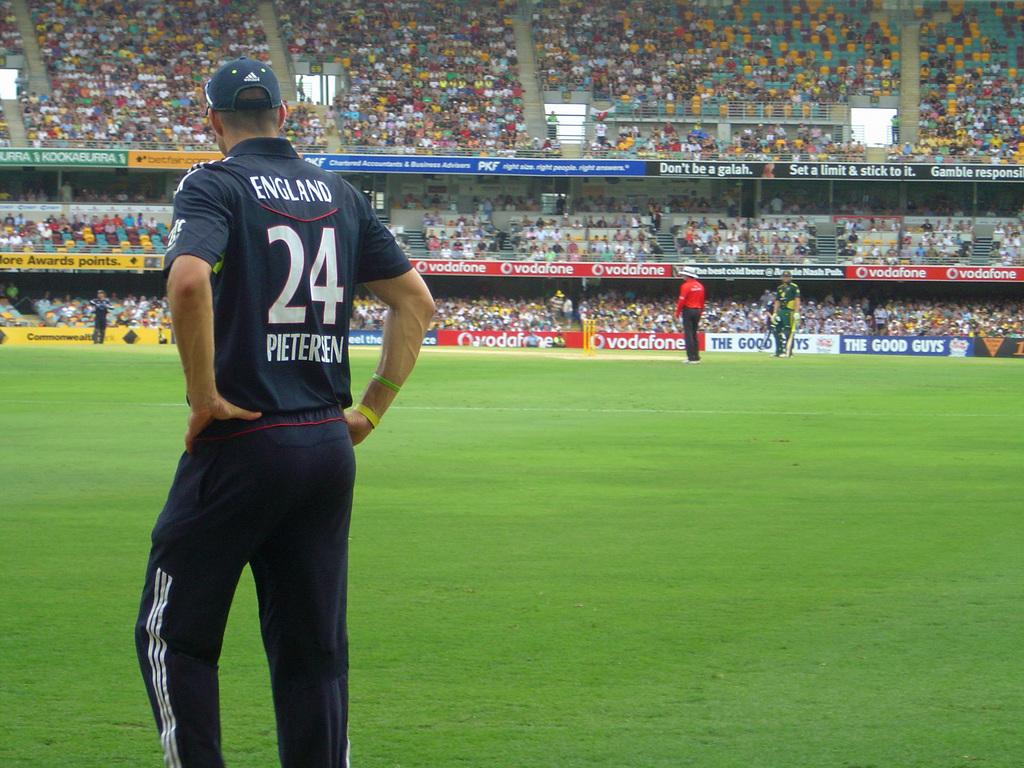What is the number on the jersey?
Keep it short and to the point. 24. 